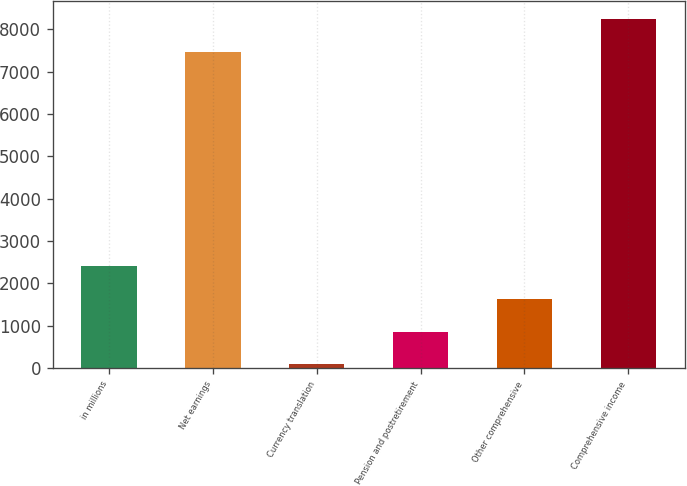Convert chart. <chart><loc_0><loc_0><loc_500><loc_500><bar_chart><fcel>in millions<fcel>Net earnings<fcel>Currency translation<fcel>Pension and postretirement<fcel>Other comprehensive<fcel>Comprehensive income<nl><fcel>2401.7<fcel>7475<fcel>89<fcel>859.9<fcel>1630.8<fcel>8245.9<nl></chart> 